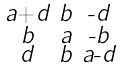<formula> <loc_0><loc_0><loc_500><loc_500>\begin{smallmatrix} a \text {+} d & b & \text {-} d \\ b & a & \text {-} b \\ d & b & a \text {-} d \end{smallmatrix}</formula> 